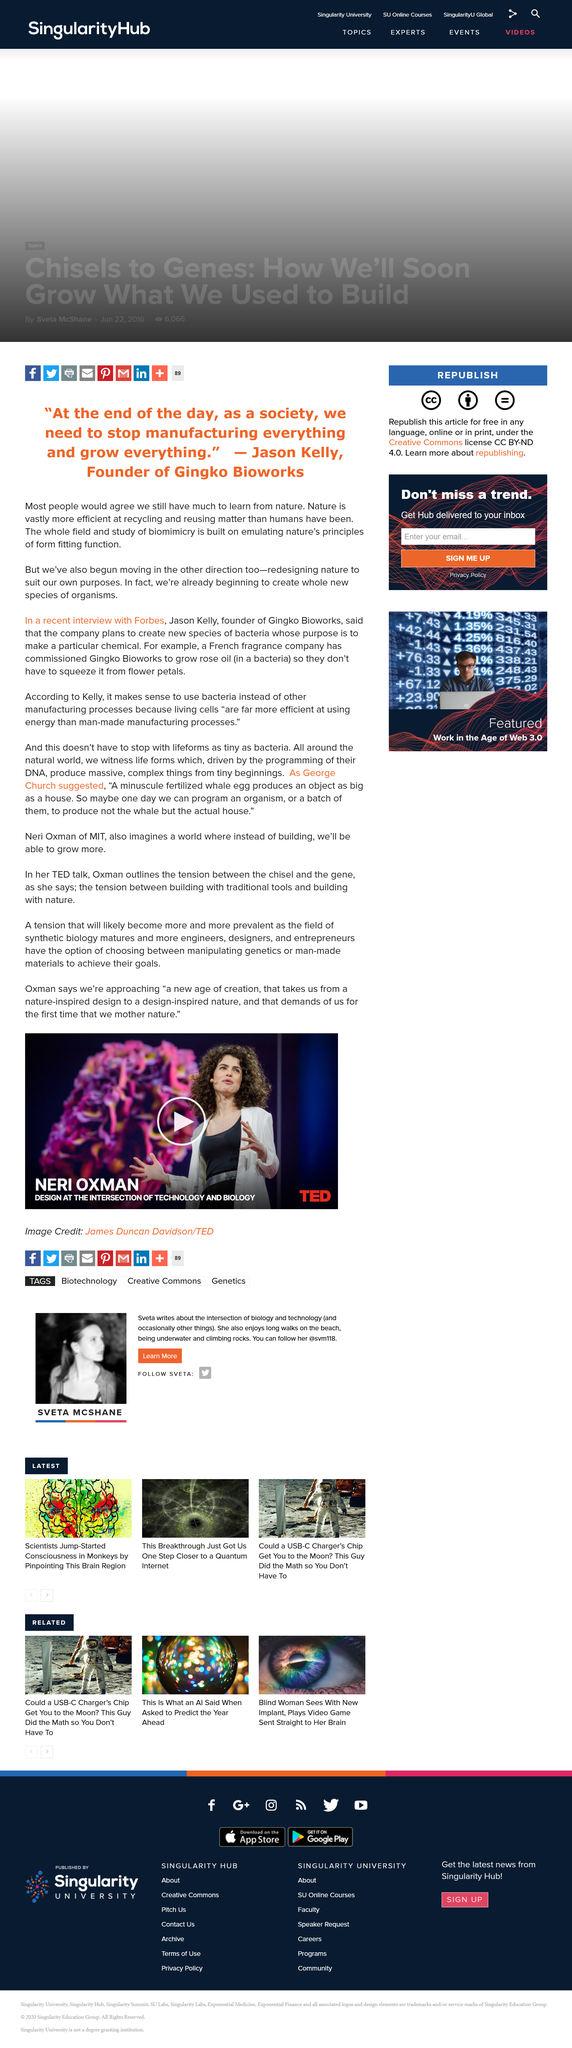Point out several critical features in this image. Oxman presents her ideas at a TED talk conference. The subject of this TED talk conference is the intersection of design between technology and biology. In her presentation, Oxman highlights the contrast between nature-inspired and design-inspired approaches to designing with nature, as well as the growing availability of alternative tools and materials for professionals in related fields. 